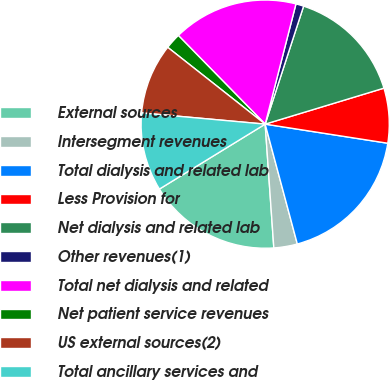<chart> <loc_0><loc_0><loc_500><loc_500><pie_chart><fcel>External sources<fcel>Intersegment revenues<fcel>Total dialysis and related lab<fcel>Less Provision for<fcel>Net dialysis and related lab<fcel>Other revenues(1)<fcel>Total net dialysis and related<fcel>Net patient service revenues<fcel>US external sources(2)<fcel>Total ancillary services and<nl><fcel>17.34%<fcel>3.06%<fcel>18.36%<fcel>7.14%<fcel>15.3%<fcel>1.02%<fcel>16.32%<fcel>2.04%<fcel>9.18%<fcel>10.2%<nl></chart> 